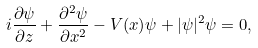<formula> <loc_0><loc_0><loc_500><loc_500>i \frac { \partial \psi } { \partial z } + \frac { \partial ^ { 2 } \psi } { \partial x ^ { 2 } } - V ( x ) \psi + | \psi | ^ { 2 } \psi = 0 ,</formula> 